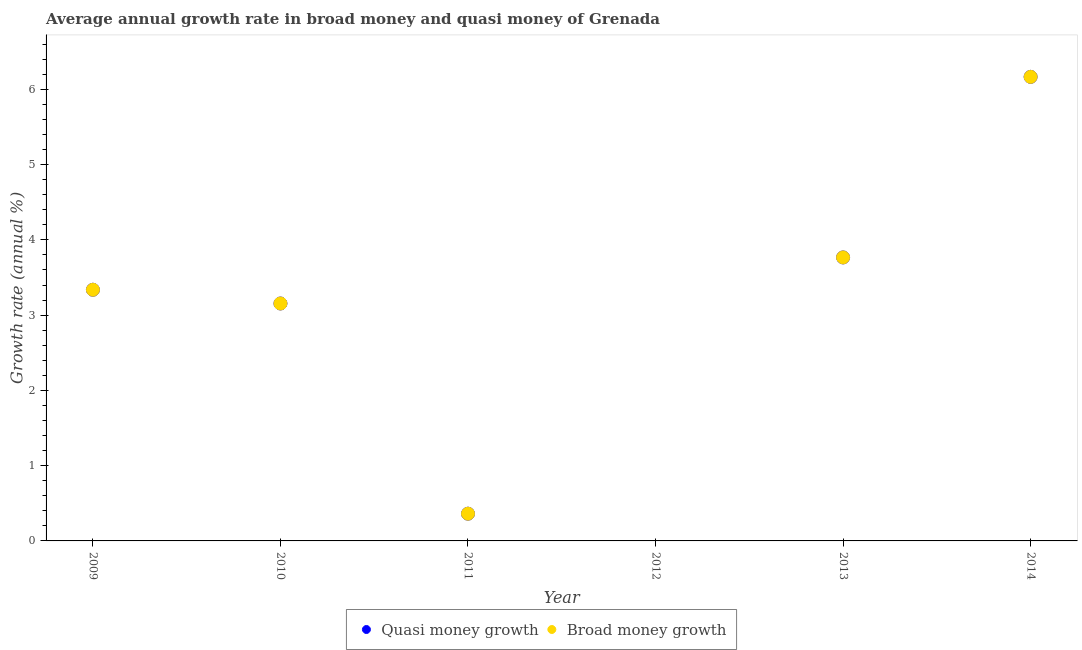How many different coloured dotlines are there?
Your answer should be compact. 2. Is the number of dotlines equal to the number of legend labels?
Ensure brevity in your answer.  No. What is the annual growth rate in broad money in 2014?
Keep it short and to the point. 6.17. Across all years, what is the maximum annual growth rate in broad money?
Your response must be concise. 6.17. Across all years, what is the minimum annual growth rate in broad money?
Offer a terse response. 0. What is the total annual growth rate in broad money in the graph?
Give a very brief answer. 16.79. What is the difference between the annual growth rate in broad money in 2013 and that in 2014?
Give a very brief answer. -2.4. What is the difference between the annual growth rate in quasi money in 2014 and the annual growth rate in broad money in 2012?
Make the answer very short. 6.17. What is the average annual growth rate in broad money per year?
Your response must be concise. 2.8. What is the ratio of the annual growth rate in quasi money in 2011 to that in 2013?
Make the answer very short. 0.1. Is the annual growth rate in broad money in 2010 less than that in 2014?
Your answer should be very brief. Yes. What is the difference between the highest and the second highest annual growth rate in broad money?
Keep it short and to the point. 2.4. What is the difference between the highest and the lowest annual growth rate in quasi money?
Your response must be concise. 6.17. How many dotlines are there?
Your answer should be very brief. 2. What is the difference between two consecutive major ticks on the Y-axis?
Give a very brief answer. 1. Are the values on the major ticks of Y-axis written in scientific E-notation?
Provide a short and direct response. No. Does the graph contain any zero values?
Give a very brief answer. Yes. Where does the legend appear in the graph?
Offer a terse response. Bottom center. How many legend labels are there?
Give a very brief answer. 2. How are the legend labels stacked?
Give a very brief answer. Horizontal. What is the title of the graph?
Your response must be concise. Average annual growth rate in broad money and quasi money of Grenada. What is the label or title of the Y-axis?
Offer a terse response. Growth rate (annual %). What is the Growth rate (annual %) in Quasi money growth in 2009?
Give a very brief answer. 3.34. What is the Growth rate (annual %) of Broad money growth in 2009?
Your response must be concise. 3.34. What is the Growth rate (annual %) in Quasi money growth in 2010?
Keep it short and to the point. 3.15. What is the Growth rate (annual %) in Broad money growth in 2010?
Offer a terse response. 3.15. What is the Growth rate (annual %) of Quasi money growth in 2011?
Give a very brief answer. 0.36. What is the Growth rate (annual %) in Broad money growth in 2011?
Your answer should be compact. 0.36. What is the Growth rate (annual %) of Broad money growth in 2012?
Keep it short and to the point. 0. What is the Growth rate (annual %) in Quasi money growth in 2013?
Your answer should be compact. 3.77. What is the Growth rate (annual %) of Broad money growth in 2013?
Your answer should be very brief. 3.77. What is the Growth rate (annual %) of Quasi money growth in 2014?
Offer a terse response. 6.17. What is the Growth rate (annual %) in Broad money growth in 2014?
Keep it short and to the point. 6.17. Across all years, what is the maximum Growth rate (annual %) in Quasi money growth?
Make the answer very short. 6.17. Across all years, what is the maximum Growth rate (annual %) of Broad money growth?
Provide a short and direct response. 6.17. Across all years, what is the minimum Growth rate (annual %) of Quasi money growth?
Your answer should be very brief. 0. What is the total Growth rate (annual %) in Quasi money growth in the graph?
Provide a succinct answer. 16.79. What is the total Growth rate (annual %) in Broad money growth in the graph?
Offer a terse response. 16.79. What is the difference between the Growth rate (annual %) in Quasi money growth in 2009 and that in 2010?
Provide a succinct answer. 0.18. What is the difference between the Growth rate (annual %) in Broad money growth in 2009 and that in 2010?
Give a very brief answer. 0.18. What is the difference between the Growth rate (annual %) of Quasi money growth in 2009 and that in 2011?
Your response must be concise. 2.98. What is the difference between the Growth rate (annual %) in Broad money growth in 2009 and that in 2011?
Your answer should be compact. 2.98. What is the difference between the Growth rate (annual %) of Quasi money growth in 2009 and that in 2013?
Offer a terse response. -0.43. What is the difference between the Growth rate (annual %) of Broad money growth in 2009 and that in 2013?
Provide a succinct answer. -0.43. What is the difference between the Growth rate (annual %) in Quasi money growth in 2009 and that in 2014?
Your answer should be compact. -2.83. What is the difference between the Growth rate (annual %) of Broad money growth in 2009 and that in 2014?
Your answer should be compact. -2.83. What is the difference between the Growth rate (annual %) in Quasi money growth in 2010 and that in 2011?
Provide a succinct answer. 2.79. What is the difference between the Growth rate (annual %) of Broad money growth in 2010 and that in 2011?
Ensure brevity in your answer.  2.79. What is the difference between the Growth rate (annual %) in Quasi money growth in 2010 and that in 2013?
Ensure brevity in your answer.  -0.61. What is the difference between the Growth rate (annual %) of Broad money growth in 2010 and that in 2013?
Offer a very short reply. -0.61. What is the difference between the Growth rate (annual %) in Quasi money growth in 2010 and that in 2014?
Give a very brief answer. -3.01. What is the difference between the Growth rate (annual %) in Broad money growth in 2010 and that in 2014?
Offer a very short reply. -3.01. What is the difference between the Growth rate (annual %) of Quasi money growth in 2011 and that in 2013?
Give a very brief answer. -3.4. What is the difference between the Growth rate (annual %) in Broad money growth in 2011 and that in 2013?
Offer a very short reply. -3.4. What is the difference between the Growth rate (annual %) of Quasi money growth in 2011 and that in 2014?
Make the answer very short. -5.8. What is the difference between the Growth rate (annual %) of Broad money growth in 2011 and that in 2014?
Provide a succinct answer. -5.8. What is the difference between the Growth rate (annual %) of Quasi money growth in 2013 and that in 2014?
Keep it short and to the point. -2.4. What is the difference between the Growth rate (annual %) of Broad money growth in 2013 and that in 2014?
Offer a very short reply. -2.4. What is the difference between the Growth rate (annual %) of Quasi money growth in 2009 and the Growth rate (annual %) of Broad money growth in 2010?
Your response must be concise. 0.18. What is the difference between the Growth rate (annual %) of Quasi money growth in 2009 and the Growth rate (annual %) of Broad money growth in 2011?
Keep it short and to the point. 2.98. What is the difference between the Growth rate (annual %) of Quasi money growth in 2009 and the Growth rate (annual %) of Broad money growth in 2013?
Ensure brevity in your answer.  -0.43. What is the difference between the Growth rate (annual %) in Quasi money growth in 2009 and the Growth rate (annual %) in Broad money growth in 2014?
Your response must be concise. -2.83. What is the difference between the Growth rate (annual %) in Quasi money growth in 2010 and the Growth rate (annual %) in Broad money growth in 2011?
Ensure brevity in your answer.  2.79. What is the difference between the Growth rate (annual %) in Quasi money growth in 2010 and the Growth rate (annual %) in Broad money growth in 2013?
Provide a succinct answer. -0.61. What is the difference between the Growth rate (annual %) in Quasi money growth in 2010 and the Growth rate (annual %) in Broad money growth in 2014?
Your answer should be very brief. -3.01. What is the difference between the Growth rate (annual %) in Quasi money growth in 2011 and the Growth rate (annual %) in Broad money growth in 2013?
Your response must be concise. -3.4. What is the difference between the Growth rate (annual %) in Quasi money growth in 2011 and the Growth rate (annual %) in Broad money growth in 2014?
Keep it short and to the point. -5.8. What is the difference between the Growth rate (annual %) in Quasi money growth in 2013 and the Growth rate (annual %) in Broad money growth in 2014?
Provide a short and direct response. -2.4. What is the average Growth rate (annual %) in Quasi money growth per year?
Give a very brief answer. 2.8. What is the average Growth rate (annual %) of Broad money growth per year?
Provide a succinct answer. 2.8. In the year 2010, what is the difference between the Growth rate (annual %) of Quasi money growth and Growth rate (annual %) of Broad money growth?
Give a very brief answer. 0. In the year 2013, what is the difference between the Growth rate (annual %) in Quasi money growth and Growth rate (annual %) in Broad money growth?
Give a very brief answer. 0. In the year 2014, what is the difference between the Growth rate (annual %) in Quasi money growth and Growth rate (annual %) in Broad money growth?
Your response must be concise. 0. What is the ratio of the Growth rate (annual %) of Quasi money growth in 2009 to that in 2010?
Make the answer very short. 1.06. What is the ratio of the Growth rate (annual %) of Broad money growth in 2009 to that in 2010?
Provide a short and direct response. 1.06. What is the ratio of the Growth rate (annual %) of Quasi money growth in 2009 to that in 2011?
Give a very brief answer. 9.22. What is the ratio of the Growth rate (annual %) of Broad money growth in 2009 to that in 2011?
Offer a terse response. 9.22. What is the ratio of the Growth rate (annual %) of Quasi money growth in 2009 to that in 2013?
Keep it short and to the point. 0.89. What is the ratio of the Growth rate (annual %) in Broad money growth in 2009 to that in 2013?
Offer a terse response. 0.89. What is the ratio of the Growth rate (annual %) of Quasi money growth in 2009 to that in 2014?
Your response must be concise. 0.54. What is the ratio of the Growth rate (annual %) in Broad money growth in 2009 to that in 2014?
Give a very brief answer. 0.54. What is the ratio of the Growth rate (annual %) in Quasi money growth in 2010 to that in 2011?
Offer a terse response. 8.72. What is the ratio of the Growth rate (annual %) of Broad money growth in 2010 to that in 2011?
Offer a terse response. 8.72. What is the ratio of the Growth rate (annual %) in Quasi money growth in 2010 to that in 2013?
Give a very brief answer. 0.84. What is the ratio of the Growth rate (annual %) of Broad money growth in 2010 to that in 2013?
Make the answer very short. 0.84. What is the ratio of the Growth rate (annual %) in Quasi money growth in 2010 to that in 2014?
Your answer should be very brief. 0.51. What is the ratio of the Growth rate (annual %) of Broad money growth in 2010 to that in 2014?
Provide a succinct answer. 0.51. What is the ratio of the Growth rate (annual %) in Quasi money growth in 2011 to that in 2013?
Your answer should be compact. 0.1. What is the ratio of the Growth rate (annual %) in Broad money growth in 2011 to that in 2013?
Give a very brief answer. 0.1. What is the ratio of the Growth rate (annual %) of Quasi money growth in 2011 to that in 2014?
Keep it short and to the point. 0.06. What is the ratio of the Growth rate (annual %) in Broad money growth in 2011 to that in 2014?
Offer a terse response. 0.06. What is the ratio of the Growth rate (annual %) in Quasi money growth in 2013 to that in 2014?
Keep it short and to the point. 0.61. What is the ratio of the Growth rate (annual %) of Broad money growth in 2013 to that in 2014?
Your response must be concise. 0.61. What is the difference between the highest and the second highest Growth rate (annual %) in Quasi money growth?
Offer a terse response. 2.4. What is the difference between the highest and the second highest Growth rate (annual %) in Broad money growth?
Provide a succinct answer. 2.4. What is the difference between the highest and the lowest Growth rate (annual %) in Quasi money growth?
Give a very brief answer. 6.17. What is the difference between the highest and the lowest Growth rate (annual %) in Broad money growth?
Offer a very short reply. 6.17. 